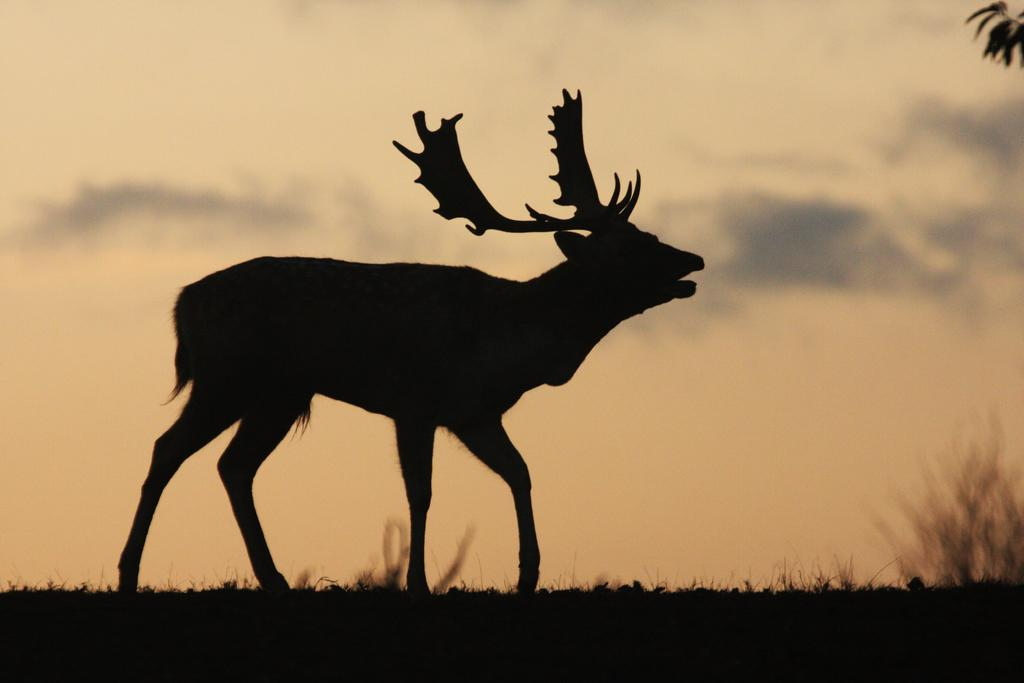What is the color scheme of the image? The image is in black and white. What animal can be seen in the image? There is a deer in the image. What type of vegetation is present in the image? There is grass in the image. What type of pie is being served to the bear in the image? There is no bear or pie present in the image; it features a deer and grass. What musical instrument is the deer playing in the image? There is no musical instrument present in the image; the deer is simply standing in the grass. 